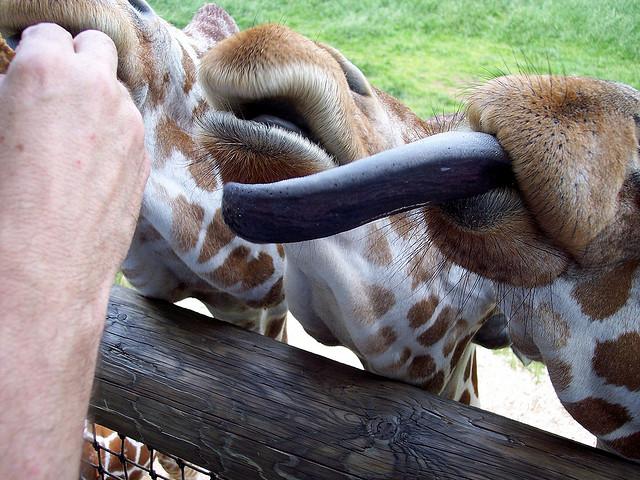What color is the animals tongue?
Keep it brief. Black. What is under the giraffe's chins?
Give a very brief answer. Fence. Are these animals in the wild?
Short answer required. No. 